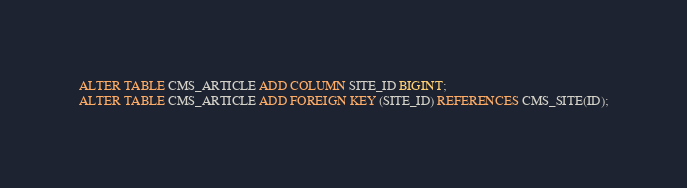Convert code to text. <code><loc_0><loc_0><loc_500><loc_500><_SQL_>

ALTER TABLE CMS_ARTICLE ADD COLUMN SITE_ID BIGINT;
ALTER TABLE CMS_ARTICLE ADD FOREIGN KEY (SITE_ID) REFERENCES CMS_SITE(ID);

</code> 